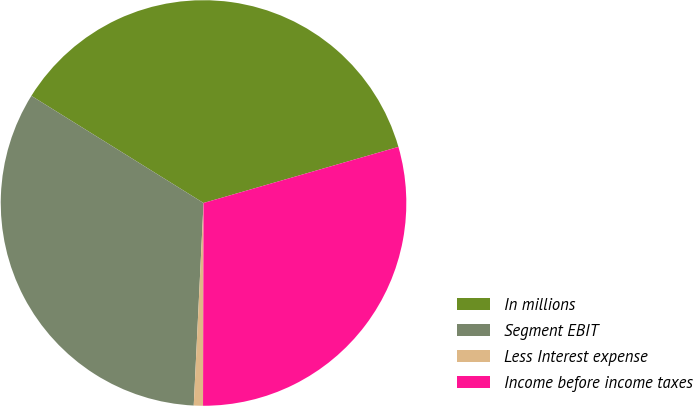Convert chart to OTSL. <chart><loc_0><loc_0><loc_500><loc_500><pie_chart><fcel>In millions<fcel>Segment EBIT<fcel>Less Interest expense<fcel>Income before income taxes<nl><fcel>36.68%<fcel>33.09%<fcel>0.73%<fcel>29.5%<nl></chart> 